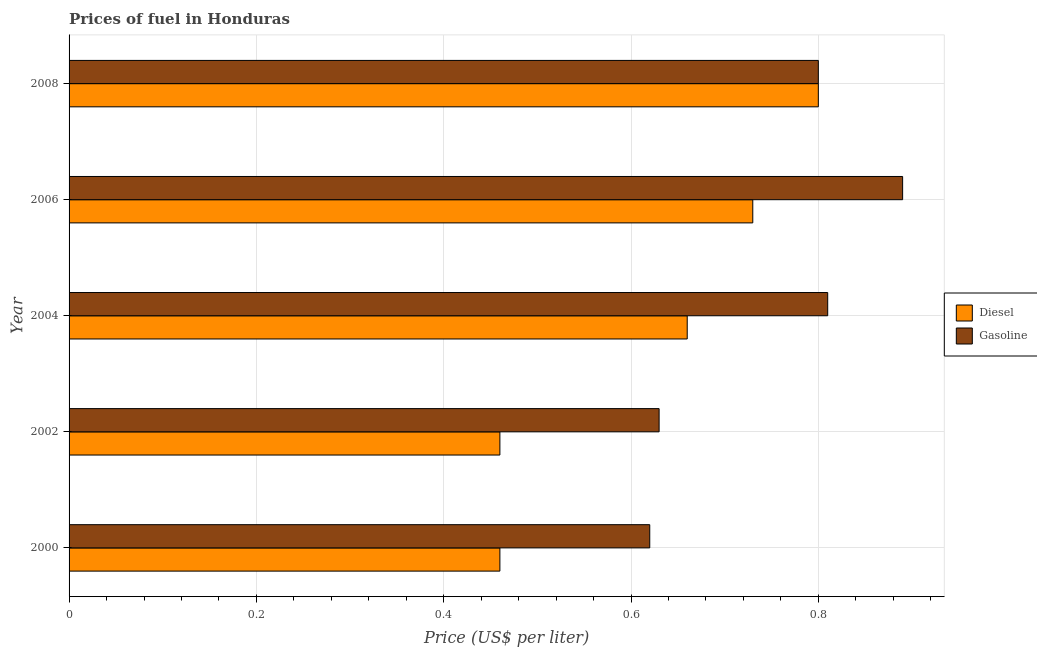How many groups of bars are there?
Offer a very short reply. 5. How many bars are there on the 5th tick from the top?
Your response must be concise. 2. How many bars are there on the 5th tick from the bottom?
Provide a succinct answer. 2. What is the label of the 2nd group of bars from the top?
Ensure brevity in your answer.  2006. What is the gasoline price in 2002?
Your response must be concise. 0.63. Across all years, what is the maximum diesel price?
Your response must be concise. 0.8. Across all years, what is the minimum diesel price?
Offer a terse response. 0.46. In which year was the diesel price maximum?
Your response must be concise. 2008. What is the total diesel price in the graph?
Your answer should be compact. 3.11. What is the difference between the diesel price in 2002 and that in 2008?
Your answer should be very brief. -0.34. What is the difference between the gasoline price in 2008 and the diesel price in 2000?
Ensure brevity in your answer.  0.34. What is the average diesel price per year?
Ensure brevity in your answer.  0.62. In the year 2000, what is the difference between the diesel price and gasoline price?
Offer a terse response. -0.16. In how many years, is the diesel price greater than 0.48000000000000004 US$ per litre?
Your response must be concise. 3. What is the difference between the highest and the second highest diesel price?
Ensure brevity in your answer.  0.07. What is the difference between the highest and the lowest gasoline price?
Offer a terse response. 0.27. In how many years, is the diesel price greater than the average diesel price taken over all years?
Make the answer very short. 3. What does the 2nd bar from the top in 2000 represents?
Give a very brief answer. Diesel. What does the 2nd bar from the bottom in 2006 represents?
Offer a very short reply. Gasoline. How many bars are there?
Keep it short and to the point. 10. Are the values on the major ticks of X-axis written in scientific E-notation?
Your response must be concise. No. Does the graph contain grids?
Offer a terse response. Yes. Where does the legend appear in the graph?
Provide a short and direct response. Center right. What is the title of the graph?
Make the answer very short. Prices of fuel in Honduras. What is the label or title of the X-axis?
Offer a very short reply. Price (US$ per liter). What is the Price (US$ per liter) in Diesel in 2000?
Your response must be concise. 0.46. What is the Price (US$ per liter) in Gasoline in 2000?
Keep it short and to the point. 0.62. What is the Price (US$ per liter) in Diesel in 2002?
Provide a short and direct response. 0.46. What is the Price (US$ per liter) of Gasoline in 2002?
Ensure brevity in your answer.  0.63. What is the Price (US$ per liter) of Diesel in 2004?
Offer a very short reply. 0.66. What is the Price (US$ per liter) in Gasoline in 2004?
Give a very brief answer. 0.81. What is the Price (US$ per liter) of Diesel in 2006?
Offer a terse response. 0.73. What is the Price (US$ per liter) of Gasoline in 2006?
Your response must be concise. 0.89. What is the Price (US$ per liter) in Gasoline in 2008?
Ensure brevity in your answer.  0.8. Across all years, what is the maximum Price (US$ per liter) of Gasoline?
Provide a succinct answer. 0.89. Across all years, what is the minimum Price (US$ per liter) in Diesel?
Provide a succinct answer. 0.46. Across all years, what is the minimum Price (US$ per liter) in Gasoline?
Make the answer very short. 0.62. What is the total Price (US$ per liter) of Diesel in the graph?
Provide a succinct answer. 3.11. What is the total Price (US$ per liter) in Gasoline in the graph?
Give a very brief answer. 3.75. What is the difference between the Price (US$ per liter) in Diesel in 2000 and that in 2002?
Offer a very short reply. 0. What is the difference between the Price (US$ per liter) of Gasoline in 2000 and that in 2002?
Keep it short and to the point. -0.01. What is the difference between the Price (US$ per liter) in Gasoline in 2000 and that in 2004?
Provide a short and direct response. -0.19. What is the difference between the Price (US$ per liter) of Diesel in 2000 and that in 2006?
Make the answer very short. -0.27. What is the difference between the Price (US$ per liter) of Gasoline in 2000 and that in 2006?
Keep it short and to the point. -0.27. What is the difference between the Price (US$ per liter) in Diesel in 2000 and that in 2008?
Make the answer very short. -0.34. What is the difference between the Price (US$ per liter) in Gasoline in 2000 and that in 2008?
Keep it short and to the point. -0.18. What is the difference between the Price (US$ per liter) in Gasoline in 2002 and that in 2004?
Keep it short and to the point. -0.18. What is the difference between the Price (US$ per liter) in Diesel in 2002 and that in 2006?
Ensure brevity in your answer.  -0.27. What is the difference between the Price (US$ per liter) of Gasoline in 2002 and that in 2006?
Your response must be concise. -0.26. What is the difference between the Price (US$ per liter) in Diesel in 2002 and that in 2008?
Your response must be concise. -0.34. What is the difference between the Price (US$ per liter) in Gasoline in 2002 and that in 2008?
Make the answer very short. -0.17. What is the difference between the Price (US$ per liter) of Diesel in 2004 and that in 2006?
Keep it short and to the point. -0.07. What is the difference between the Price (US$ per liter) in Gasoline in 2004 and that in 2006?
Your answer should be compact. -0.08. What is the difference between the Price (US$ per liter) in Diesel in 2004 and that in 2008?
Provide a succinct answer. -0.14. What is the difference between the Price (US$ per liter) in Diesel in 2006 and that in 2008?
Keep it short and to the point. -0.07. What is the difference between the Price (US$ per liter) of Gasoline in 2006 and that in 2008?
Your answer should be very brief. 0.09. What is the difference between the Price (US$ per liter) in Diesel in 2000 and the Price (US$ per liter) in Gasoline in 2002?
Keep it short and to the point. -0.17. What is the difference between the Price (US$ per liter) of Diesel in 2000 and the Price (US$ per liter) of Gasoline in 2004?
Your answer should be very brief. -0.35. What is the difference between the Price (US$ per liter) of Diesel in 2000 and the Price (US$ per liter) of Gasoline in 2006?
Make the answer very short. -0.43. What is the difference between the Price (US$ per liter) in Diesel in 2000 and the Price (US$ per liter) in Gasoline in 2008?
Your answer should be compact. -0.34. What is the difference between the Price (US$ per liter) in Diesel in 2002 and the Price (US$ per liter) in Gasoline in 2004?
Offer a very short reply. -0.35. What is the difference between the Price (US$ per liter) in Diesel in 2002 and the Price (US$ per liter) in Gasoline in 2006?
Ensure brevity in your answer.  -0.43. What is the difference between the Price (US$ per liter) of Diesel in 2002 and the Price (US$ per liter) of Gasoline in 2008?
Your answer should be compact. -0.34. What is the difference between the Price (US$ per liter) in Diesel in 2004 and the Price (US$ per liter) in Gasoline in 2006?
Your answer should be compact. -0.23. What is the difference between the Price (US$ per liter) in Diesel in 2004 and the Price (US$ per liter) in Gasoline in 2008?
Offer a terse response. -0.14. What is the difference between the Price (US$ per liter) in Diesel in 2006 and the Price (US$ per liter) in Gasoline in 2008?
Provide a succinct answer. -0.07. What is the average Price (US$ per liter) of Diesel per year?
Provide a short and direct response. 0.62. What is the average Price (US$ per liter) in Gasoline per year?
Make the answer very short. 0.75. In the year 2000, what is the difference between the Price (US$ per liter) in Diesel and Price (US$ per liter) in Gasoline?
Provide a short and direct response. -0.16. In the year 2002, what is the difference between the Price (US$ per liter) of Diesel and Price (US$ per liter) of Gasoline?
Provide a short and direct response. -0.17. In the year 2004, what is the difference between the Price (US$ per liter) of Diesel and Price (US$ per liter) of Gasoline?
Offer a terse response. -0.15. In the year 2006, what is the difference between the Price (US$ per liter) in Diesel and Price (US$ per liter) in Gasoline?
Your answer should be compact. -0.16. In the year 2008, what is the difference between the Price (US$ per liter) of Diesel and Price (US$ per liter) of Gasoline?
Your answer should be compact. 0. What is the ratio of the Price (US$ per liter) of Gasoline in 2000 to that in 2002?
Provide a succinct answer. 0.98. What is the ratio of the Price (US$ per liter) of Diesel in 2000 to that in 2004?
Offer a terse response. 0.7. What is the ratio of the Price (US$ per liter) of Gasoline in 2000 to that in 2004?
Provide a succinct answer. 0.77. What is the ratio of the Price (US$ per liter) of Diesel in 2000 to that in 2006?
Your answer should be compact. 0.63. What is the ratio of the Price (US$ per liter) of Gasoline in 2000 to that in 2006?
Offer a terse response. 0.7. What is the ratio of the Price (US$ per liter) in Diesel in 2000 to that in 2008?
Keep it short and to the point. 0.57. What is the ratio of the Price (US$ per liter) in Gasoline in 2000 to that in 2008?
Your response must be concise. 0.78. What is the ratio of the Price (US$ per liter) in Diesel in 2002 to that in 2004?
Ensure brevity in your answer.  0.7. What is the ratio of the Price (US$ per liter) of Gasoline in 2002 to that in 2004?
Provide a succinct answer. 0.78. What is the ratio of the Price (US$ per liter) of Diesel in 2002 to that in 2006?
Your answer should be compact. 0.63. What is the ratio of the Price (US$ per liter) in Gasoline in 2002 to that in 2006?
Provide a succinct answer. 0.71. What is the ratio of the Price (US$ per liter) of Diesel in 2002 to that in 2008?
Make the answer very short. 0.57. What is the ratio of the Price (US$ per liter) of Gasoline in 2002 to that in 2008?
Make the answer very short. 0.79. What is the ratio of the Price (US$ per liter) of Diesel in 2004 to that in 2006?
Ensure brevity in your answer.  0.9. What is the ratio of the Price (US$ per liter) of Gasoline in 2004 to that in 2006?
Your answer should be very brief. 0.91. What is the ratio of the Price (US$ per liter) in Diesel in 2004 to that in 2008?
Make the answer very short. 0.82. What is the ratio of the Price (US$ per liter) of Gasoline in 2004 to that in 2008?
Give a very brief answer. 1.01. What is the ratio of the Price (US$ per liter) in Diesel in 2006 to that in 2008?
Your response must be concise. 0.91. What is the ratio of the Price (US$ per liter) in Gasoline in 2006 to that in 2008?
Make the answer very short. 1.11. What is the difference between the highest and the second highest Price (US$ per liter) of Diesel?
Give a very brief answer. 0.07. What is the difference between the highest and the second highest Price (US$ per liter) of Gasoline?
Your answer should be compact. 0.08. What is the difference between the highest and the lowest Price (US$ per liter) of Diesel?
Your answer should be compact. 0.34. What is the difference between the highest and the lowest Price (US$ per liter) in Gasoline?
Keep it short and to the point. 0.27. 